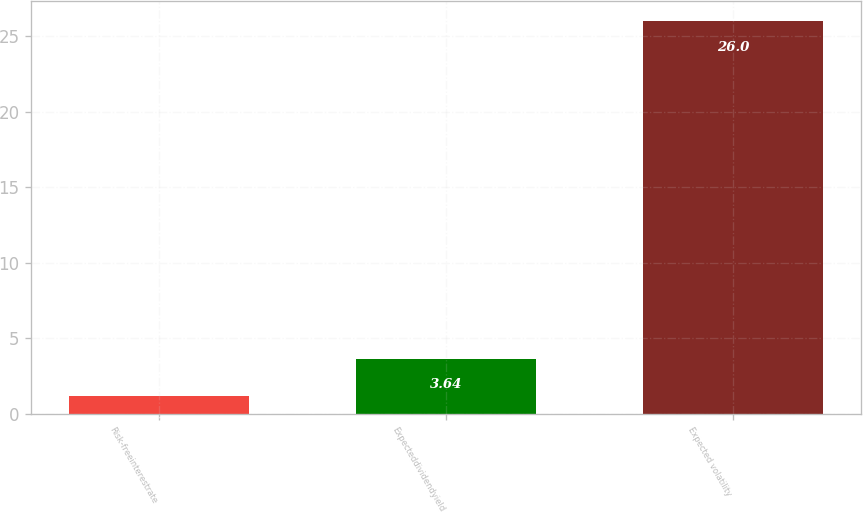Convert chart to OTSL. <chart><loc_0><loc_0><loc_500><loc_500><bar_chart><fcel>Risk-freeinterestrate<fcel>Expecteddividendyield<fcel>Expected volatility<nl><fcel>1.16<fcel>3.64<fcel>26<nl></chart> 